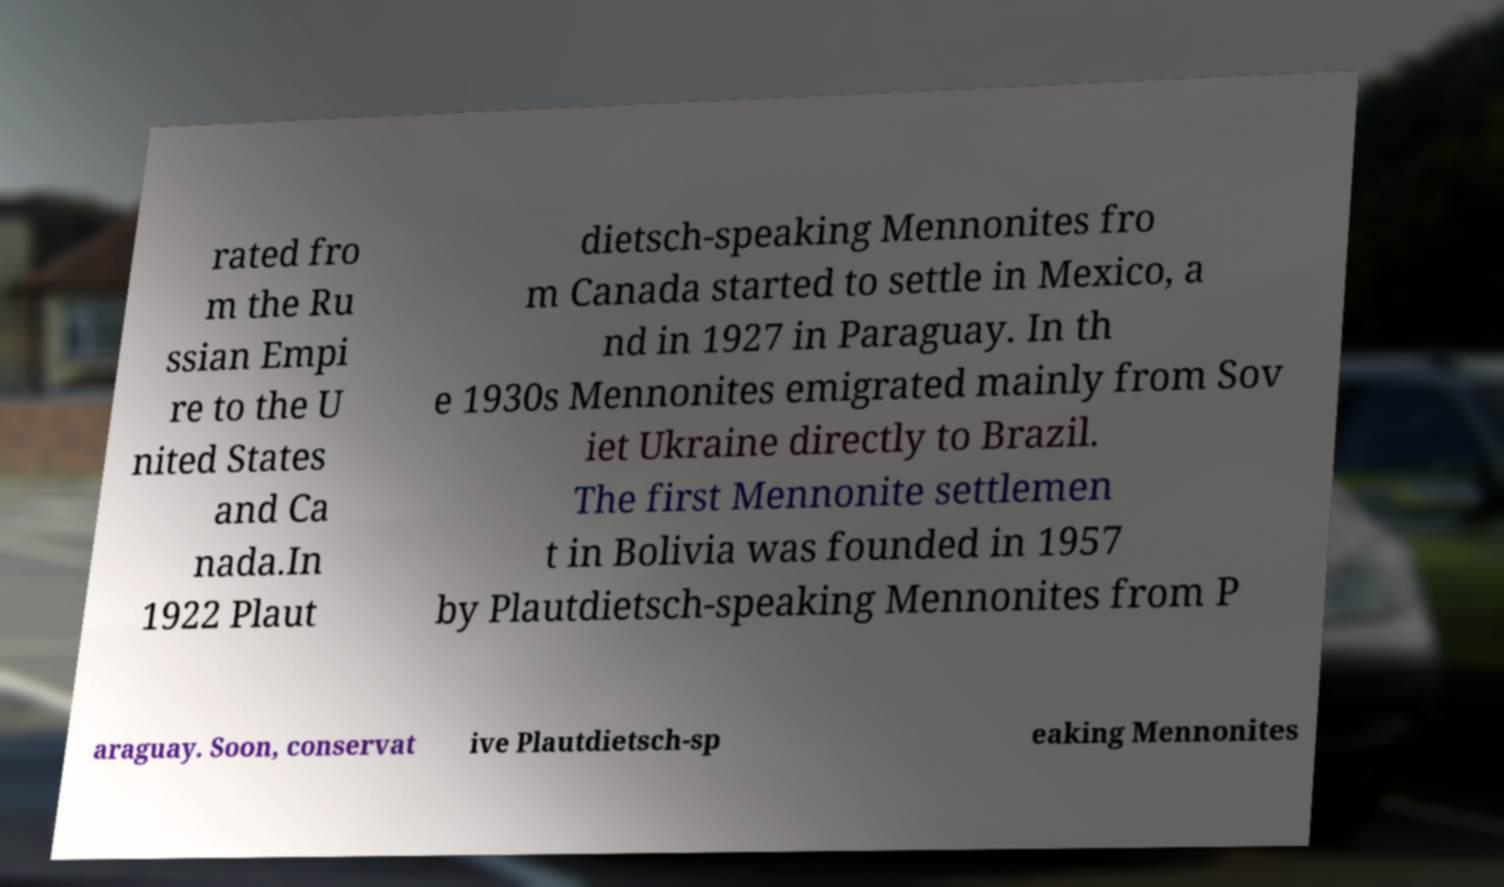Can you read and provide the text displayed in the image?This photo seems to have some interesting text. Can you extract and type it out for me? rated fro m the Ru ssian Empi re to the U nited States and Ca nada.In 1922 Plaut dietsch-speaking Mennonites fro m Canada started to settle in Mexico, a nd in 1927 in Paraguay. In th e 1930s Mennonites emigrated mainly from Sov iet Ukraine directly to Brazil. The first Mennonite settlemen t in Bolivia was founded in 1957 by Plautdietsch-speaking Mennonites from P araguay. Soon, conservat ive Plautdietsch-sp eaking Mennonites 